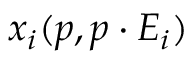Convert formula to latex. <formula><loc_0><loc_0><loc_500><loc_500>x _ { i } ( p , p \cdot E _ { i } )</formula> 